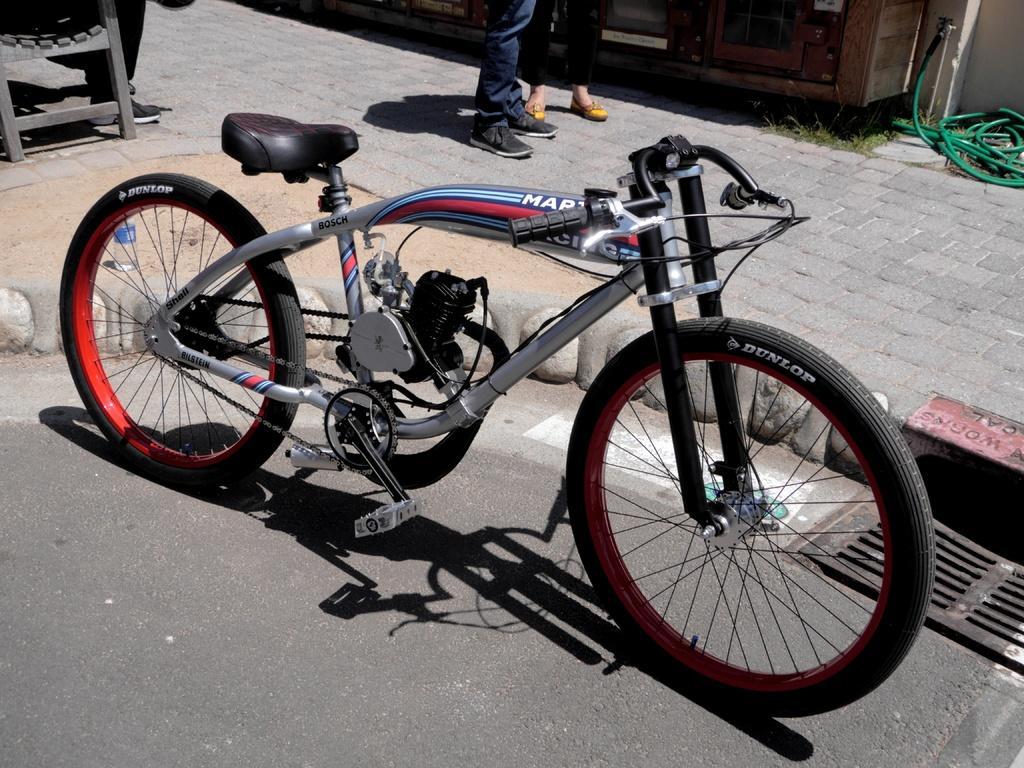In one or two sentences, can you explain what this image depicts? In the picture there is a cycle of Dunlop company beside the cycle, there is a footpath on the footpath there is a green color pipe and it looks like two persons are standing on the footpath. 